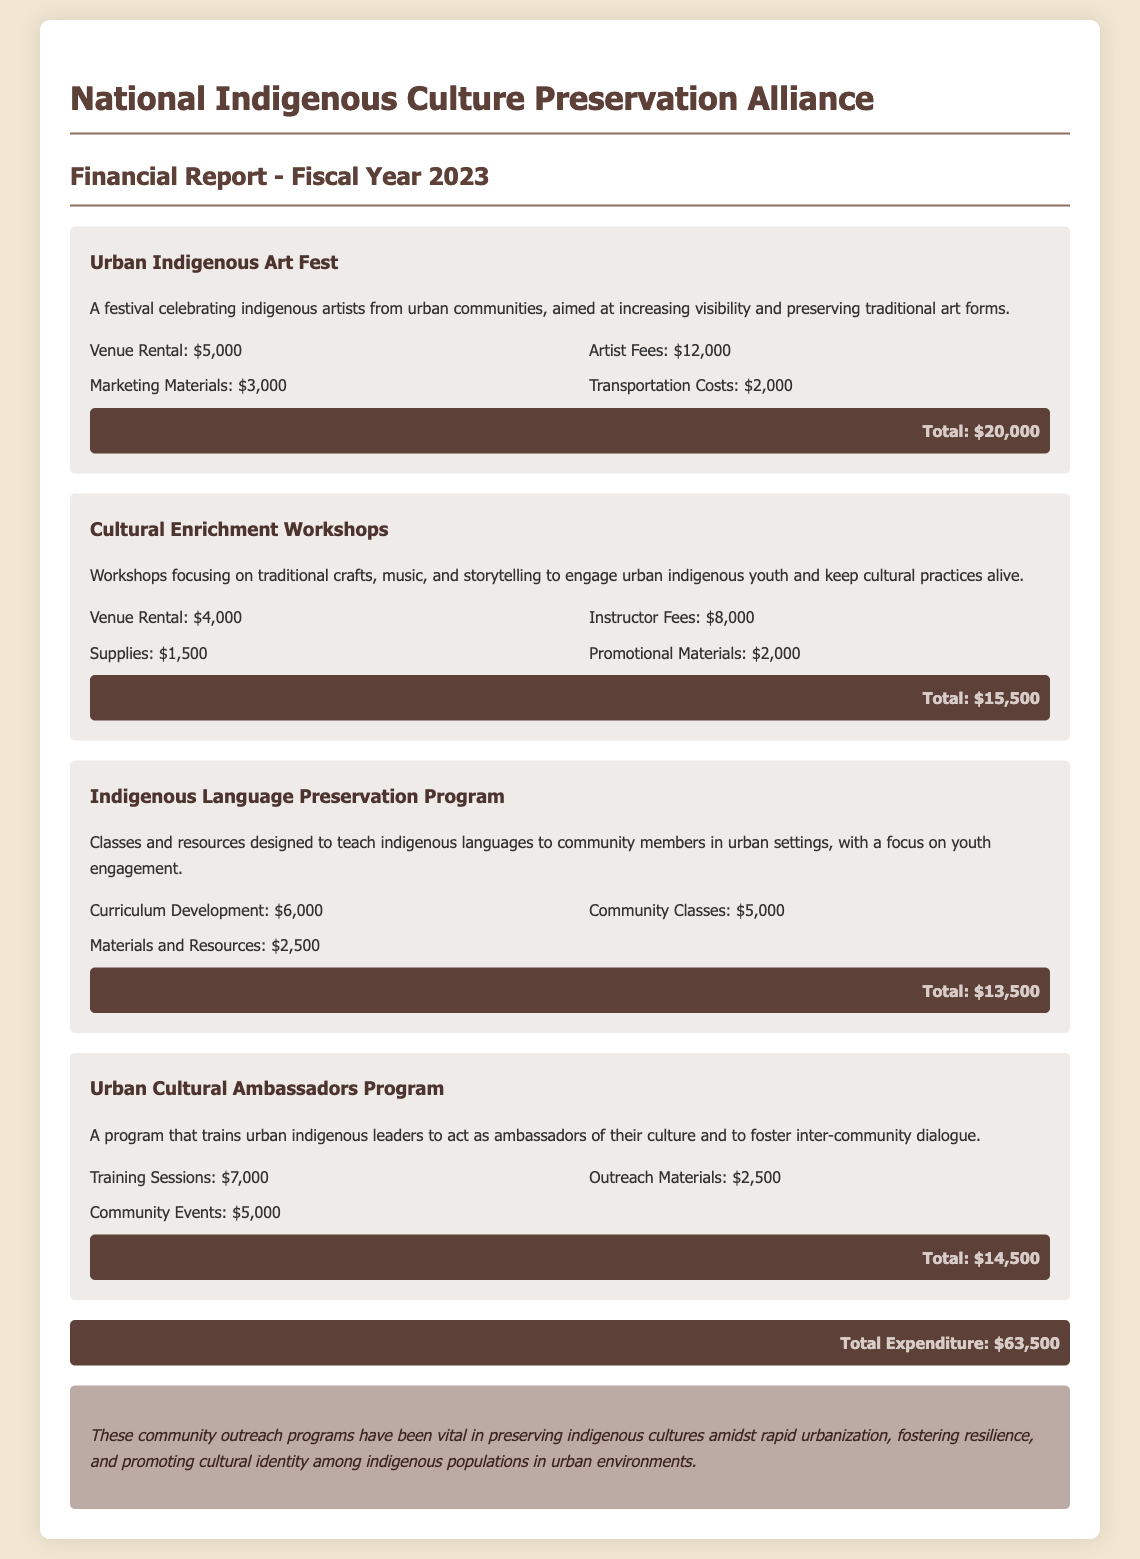What is the total expenditure for fiscal year 2023? The total expenditure is calculated by summing the expenditures across all community outreach programs listed in the document. The total comes to $20,000 + $15,500 + $13,500 + $14,500 = $63,500.
Answer: $63,500 What is the expense for Artist Fees in the Urban Indigenous Art Fest? The Artist Fees for this program are explicitly listed in the expenses section of the document.
Answer: $12,000 How many programs are detailed in the financial report? The number of programs can be counted from the sections listed in the document. There are four programs described.
Answer: 4 What type of activities do the Cultural Enrichment Workshops focus on? The description of the program clearly states the focus areas for these workshops.
Answer: Traditional crafts, music, and storytelling What is the total cost for the Indigenous Language Preservation Program? The total cost is outlined in the program section of the document after summing the individual expenses: Curriculum Development, Community Classes, and Materials and Resources.
Answer: $13,500 What is a key goal of the Urban Cultural Ambassadors Program? The document succinctly summarizes the purpose of this program in its overview.
Answer: Foster inter-community dialogue How much is allocated for venue rental across all programs? The venue rental costs for each program are detailed in the expenses sections, which can be summed to find the total.
Answer: $20,000 What impact do these community outreach programs aim to achieve? The impact statement at the end of the document outlines the overarching goal of these programs.
Answer: Preserving indigenous cultures What is the cost for Promotional Materials in the Cultural Enrichment Workshops? The expense line for this specific program lists the cost of Promotional Materials in its breakdown.
Answer: $2,000 What kind of resources are included in the Indigenous Language Preservation Program? The document specifically mentions the types of resources involved in this program to enhance its description.
Answer: Materials and Resources 